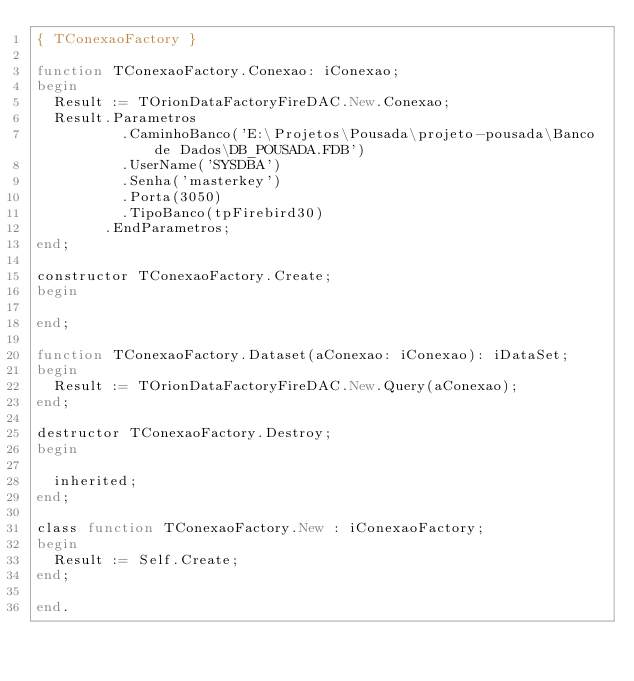<code> <loc_0><loc_0><loc_500><loc_500><_Pascal_>{ TConexaoFactory }

function TConexaoFactory.Conexao: iConexao;
begin
  Result := TOrionDataFactoryFireDAC.New.Conexao;
  Result.Parametros
          .CaminhoBanco('E:\Projetos\Pousada\projeto-pousada\Banco de Dados\DB_POUSADA.FDB')
          .UserName('SYSDBA')
          .Senha('masterkey')
          .Porta(3050)
          .TipoBanco(tpFirebird30)
        .EndParametros;
end;

constructor TConexaoFactory.Create;
begin

end;

function TConexaoFactory.Dataset(aConexao: iConexao): iDataSet;
begin
  Result := TOrionDataFactoryFireDAC.New.Query(aConexao);
end;

destructor TConexaoFactory.Destroy;
begin

  inherited;
end;

class function TConexaoFactory.New : iConexaoFactory;
begin
  Result := Self.Create;
end;

end.
</code> 